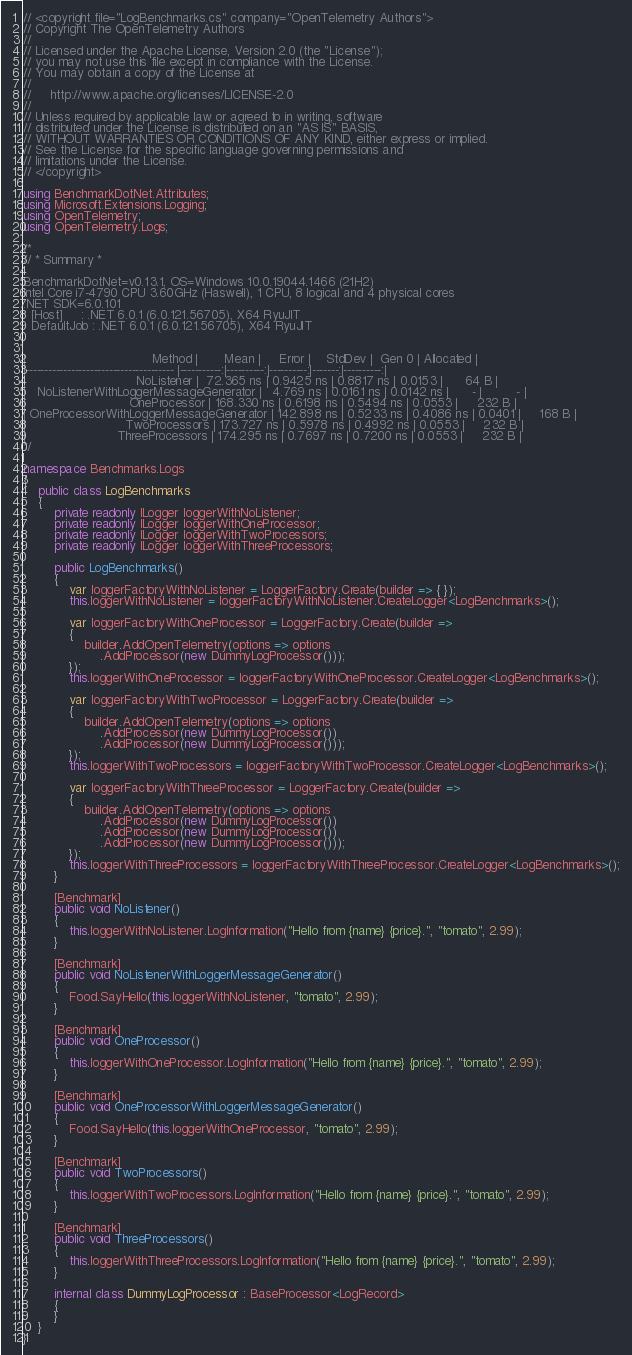<code> <loc_0><loc_0><loc_500><loc_500><_C#_>// <copyright file="LogBenchmarks.cs" company="OpenTelemetry Authors">
// Copyright The OpenTelemetry Authors
//
// Licensed under the Apache License, Version 2.0 (the "License");
// you may not use this file except in compliance with the License.
// You may obtain a copy of the License at
//
//     http://www.apache.org/licenses/LICENSE-2.0
//
// Unless required by applicable law or agreed to in writing, software
// distributed under the License is distributed on an "AS IS" BASIS,
// WITHOUT WARRANTIES OR CONDITIONS OF ANY KIND, either express or implied.
// See the License for the specific language governing permissions and
// limitations under the License.
// </copyright>

using BenchmarkDotNet.Attributes;
using Microsoft.Extensions.Logging;
using OpenTelemetry;
using OpenTelemetry.Logs;

/*
// * Summary *

BenchmarkDotNet=v0.13.1, OS=Windows 10.0.19044.1466 (21H2)
Intel Core i7-4790 CPU 3.60GHz (Haswell), 1 CPU, 8 logical and 4 physical cores
.NET SDK=6.0.101
  [Host]     : .NET 6.0.1 (6.0.121.56705), X64 RyuJIT
  DefaultJob : .NET 6.0.1 (6.0.121.56705), X64 RyuJIT


|                                 Method |       Mean |     Error |    StdDev |  Gen 0 | Allocated |
|--------------------------------------- |-----------:|----------:|----------:|-------:|----------:|
|                             NoListener |  72.365 ns | 0.9425 ns | 0.8817 ns | 0.0153 |      64 B |
|   NoListenerWithLoggerMessageGenerator |   4.769 ns | 0.0161 ns | 0.0142 ns |      - |         - |
|                           OneProcessor | 168.330 ns | 0.6198 ns | 0.5494 ns | 0.0553 |     232 B |
| OneProcessorWithLoggerMessageGenerator | 142.898 ns | 0.5233 ns | 0.4086 ns | 0.0401 |     168 B |
|                          TwoProcessors | 173.727 ns | 0.5978 ns | 0.4992 ns | 0.0553 |     232 B |
|                        ThreeProcessors | 174.295 ns | 0.7697 ns | 0.7200 ns | 0.0553 |     232 B |
*/

namespace Benchmarks.Logs
{
    public class LogBenchmarks
    {
        private readonly ILogger loggerWithNoListener;
        private readonly ILogger loggerWithOneProcessor;
        private readonly ILogger loggerWithTwoProcessors;
        private readonly ILogger loggerWithThreeProcessors;

        public LogBenchmarks()
        {
            var loggerFactoryWithNoListener = LoggerFactory.Create(builder => { });
            this.loggerWithNoListener = loggerFactoryWithNoListener.CreateLogger<LogBenchmarks>();

            var loggerFactoryWithOneProcessor = LoggerFactory.Create(builder =>
            {
                builder.AddOpenTelemetry(options => options
                    .AddProcessor(new DummyLogProcessor()));
            });
            this.loggerWithOneProcessor = loggerFactoryWithOneProcessor.CreateLogger<LogBenchmarks>();

            var loggerFactoryWithTwoProcessor = LoggerFactory.Create(builder =>
            {
                builder.AddOpenTelemetry(options => options
                    .AddProcessor(new DummyLogProcessor())
                    .AddProcessor(new DummyLogProcessor()));
            });
            this.loggerWithTwoProcessors = loggerFactoryWithTwoProcessor.CreateLogger<LogBenchmarks>();

            var loggerFactoryWithThreeProcessor = LoggerFactory.Create(builder =>
            {
                builder.AddOpenTelemetry(options => options
                    .AddProcessor(new DummyLogProcessor())
                    .AddProcessor(new DummyLogProcessor())
                    .AddProcessor(new DummyLogProcessor()));
            });
            this.loggerWithThreeProcessors = loggerFactoryWithThreeProcessor.CreateLogger<LogBenchmarks>();
        }

        [Benchmark]
        public void NoListener()
        {
            this.loggerWithNoListener.LogInformation("Hello from {name} {price}.", "tomato", 2.99);
        }

        [Benchmark]
        public void NoListenerWithLoggerMessageGenerator()
        {
            Food.SayHello(this.loggerWithNoListener, "tomato", 2.99);
        }

        [Benchmark]
        public void OneProcessor()
        {
            this.loggerWithOneProcessor.LogInformation("Hello from {name} {price}.", "tomato", 2.99);
        }

        [Benchmark]
        public void OneProcessorWithLoggerMessageGenerator()
        {
            Food.SayHello(this.loggerWithOneProcessor, "tomato", 2.99);
        }

        [Benchmark]
        public void TwoProcessors()
        {
            this.loggerWithTwoProcessors.LogInformation("Hello from {name} {price}.", "tomato", 2.99);
        }

        [Benchmark]
        public void ThreeProcessors()
        {
            this.loggerWithThreeProcessors.LogInformation("Hello from {name} {price}.", "tomato", 2.99);
        }

        internal class DummyLogProcessor : BaseProcessor<LogRecord>
        {
        }
    }
}
</code> 